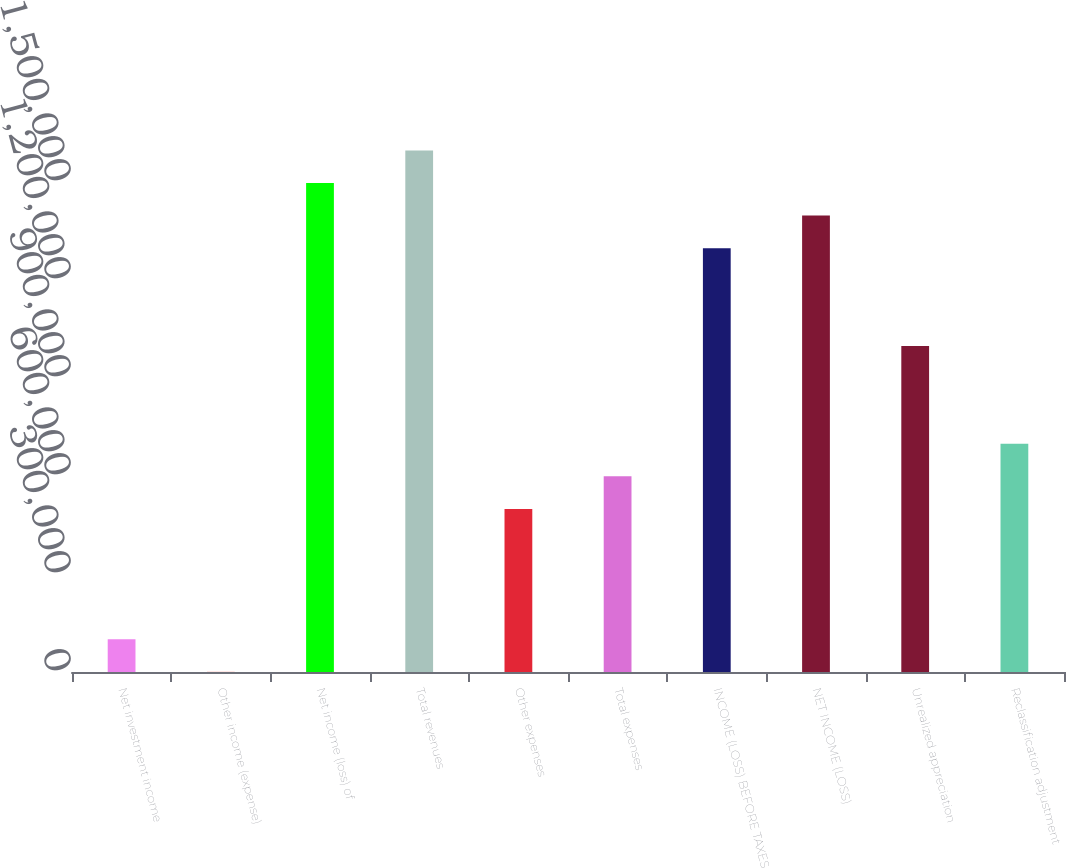Convert chart. <chart><loc_0><loc_0><loc_500><loc_500><bar_chart><fcel>Net investment income<fcel>Other income (expense)<fcel>Net income (loss) of<fcel>Total revenues<fcel>Other expenses<fcel>Total expenses<fcel>INCOME (LOSS) BEFORE TAXES<fcel>NET INCOME (LOSS)<fcel>Unrealized appreciation<fcel>Reclassification adjustment<nl><fcel>100224<fcel>459<fcel>1.49693e+06<fcel>1.5967e+06<fcel>499284<fcel>599049<fcel>1.2974e+06<fcel>1.39717e+06<fcel>998109<fcel>698814<nl></chart> 